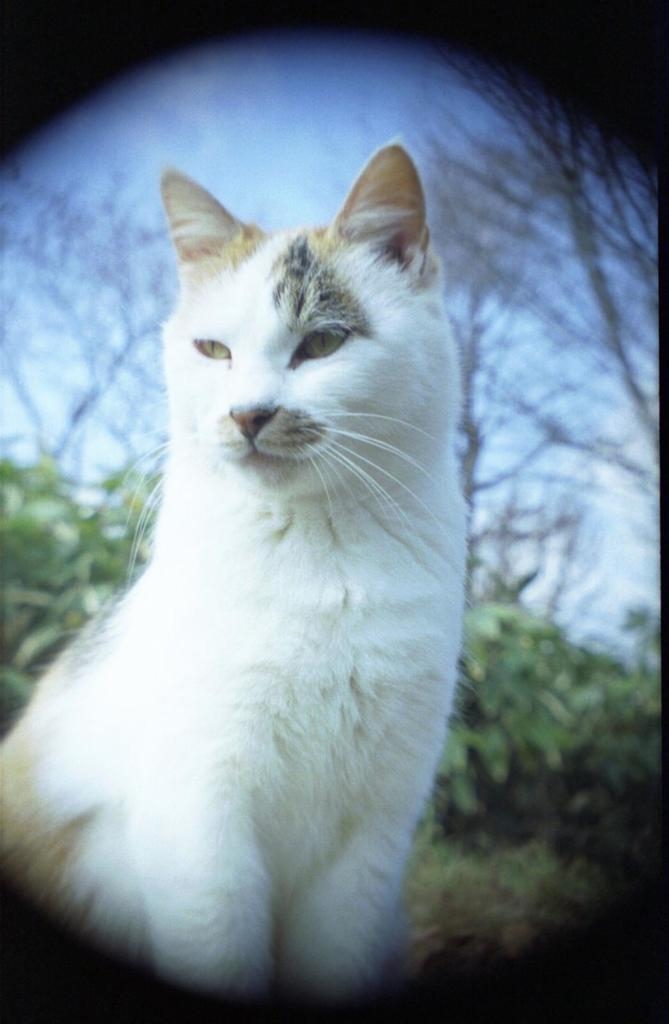What type of animal is in the image? There is a white cat in the image. What can be seen in the background of the image? There are plants, trees, and the sky visible in the background of the image. How many babies are holding a note in the image? There are no babies or notes present in the image; it features a white cat and a background with plants, trees, and the sky. 